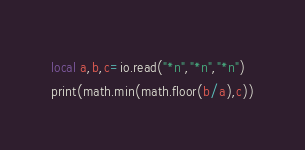<code> <loc_0><loc_0><loc_500><loc_500><_Lua_>local a,b,c=io.read("*n","*n","*n")
print(math.min(math.floor(b/a),c))</code> 